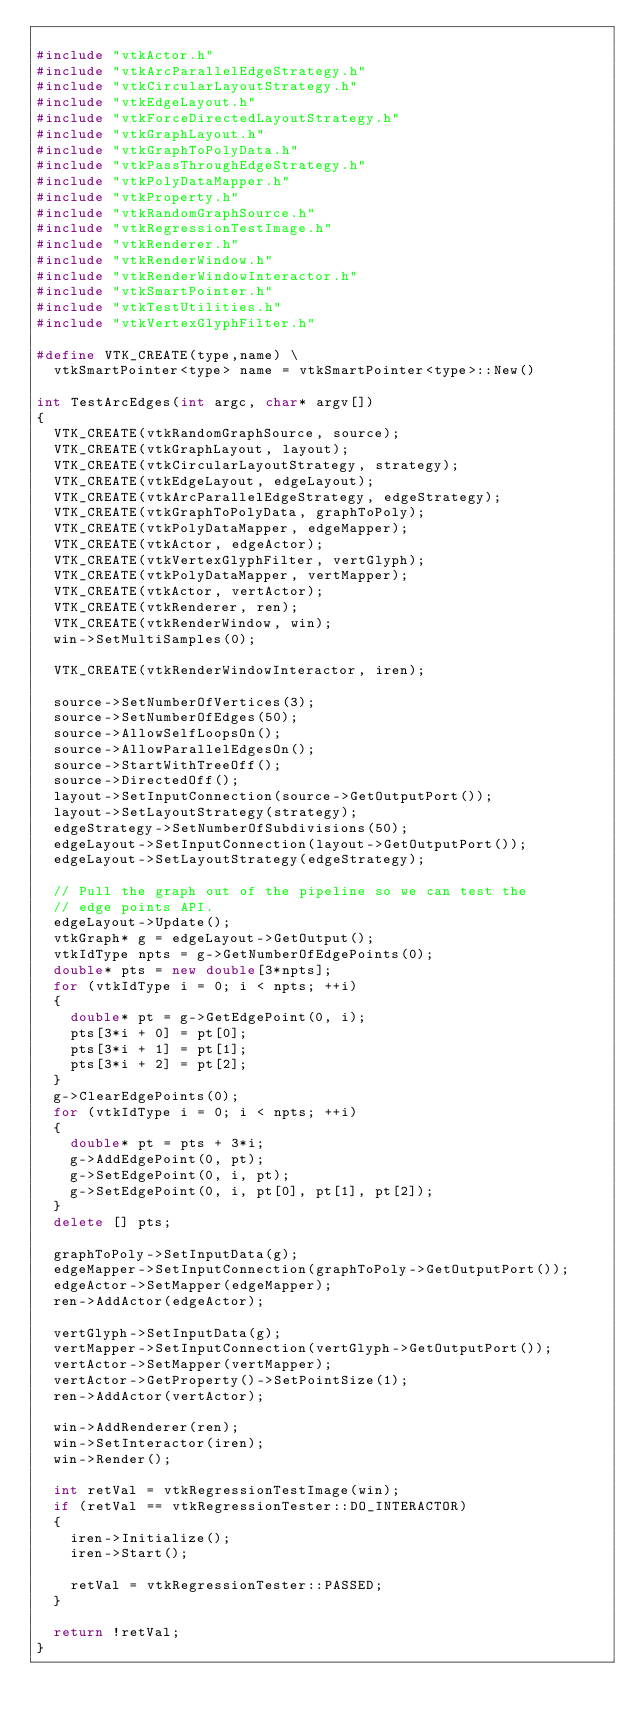Convert code to text. <code><loc_0><loc_0><loc_500><loc_500><_C++_>
#include "vtkActor.h"
#include "vtkArcParallelEdgeStrategy.h"
#include "vtkCircularLayoutStrategy.h"
#include "vtkEdgeLayout.h"
#include "vtkForceDirectedLayoutStrategy.h"
#include "vtkGraphLayout.h"
#include "vtkGraphToPolyData.h"
#include "vtkPassThroughEdgeStrategy.h"
#include "vtkPolyDataMapper.h"
#include "vtkProperty.h"
#include "vtkRandomGraphSource.h"
#include "vtkRegressionTestImage.h"
#include "vtkRenderer.h"
#include "vtkRenderWindow.h"
#include "vtkRenderWindowInteractor.h"
#include "vtkSmartPointer.h"
#include "vtkTestUtilities.h"
#include "vtkVertexGlyphFilter.h"

#define VTK_CREATE(type,name) \
  vtkSmartPointer<type> name = vtkSmartPointer<type>::New()

int TestArcEdges(int argc, char* argv[])
{
  VTK_CREATE(vtkRandomGraphSource, source);
  VTK_CREATE(vtkGraphLayout, layout);
  VTK_CREATE(vtkCircularLayoutStrategy, strategy);
  VTK_CREATE(vtkEdgeLayout, edgeLayout);
  VTK_CREATE(vtkArcParallelEdgeStrategy, edgeStrategy);
  VTK_CREATE(vtkGraphToPolyData, graphToPoly);
  VTK_CREATE(vtkPolyDataMapper, edgeMapper);
  VTK_CREATE(vtkActor, edgeActor);
  VTK_CREATE(vtkVertexGlyphFilter, vertGlyph);
  VTK_CREATE(vtkPolyDataMapper, vertMapper);
  VTK_CREATE(vtkActor, vertActor);
  VTK_CREATE(vtkRenderer, ren);
  VTK_CREATE(vtkRenderWindow, win);
  win->SetMultiSamples(0);

  VTK_CREATE(vtkRenderWindowInteractor, iren);

  source->SetNumberOfVertices(3);
  source->SetNumberOfEdges(50);
  source->AllowSelfLoopsOn();
  source->AllowParallelEdgesOn();
  source->StartWithTreeOff();
  source->DirectedOff();
  layout->SetInputConnection(source->GetOutputPort());
  layout->SetLayoutStrategy(strategy);
  edgeStrategy->SetNumberOfSubdivisions(50);
  edgeLayout->SetInputConnection(layout->GetOutputPort());
  edgeLayout->SetLayoutStrategy(edgeStrategy);

  // Pull the graph out of the pipeline so we can test the
  // edge points API.
  edgeLayout->Update();
  vtkGraph* g = edgeLayout->GetOutput();
  vtkIdType npts = g->GetNumberOfEdgePoints(0);
  double* pts = new double[3*npts];
  for (vtkIdType i = 0; i < npts; ++i)
  {
    double* pt = g->GetEdgePoint(0, i);
    pts[3*i + 0] = pt[0];
    pts[3*i + 1] = pt[1];
    pts[3*i + 2] = pt[2];
  }
  g->ClearEdgePoints(0);
  for (vtkIdType i = 0; i < npts; ++i)
  {
    double* pt = pts + 3*i;
    g->AddEdgePoint(0, pt);
    g->SetEdgePoint(0, i, pt);
    g->SetEdgePoint(0, i, pt[0], pt[1], pt[2]);
  }
  delete [] pts;

  graphToPoly->SetInputData(g);
  edgeMapper->SetInputConnection(graphToPoly->GetOutputPort());
  edgeActor->SetMapper(edgeMapper);
  ren->AddActor(edgeActor);

  vertGlyph->SetInputData(g);
  vertMapper->SetInputConnection(vertGlyph->GetOutputPort());
  vertActor->SetMapper(vertMapper);
  vertActor->GetProperty()->SetPointSize(1);
  ren->AddActor(vertActor);

  win->AddRenderer(ren);
  win->SetInteractor(iren);
  win->Render();

  int retVal = vtkRegressionTestImage(win);
  if (retVal == vtkRegressionTester::DO_INTERACTOR)
  {
    iren->Initialize();
    iren->Start();

    retVal = vtkRegressionTester::PASSED;
  }

  return !retVal;
}

</code> 